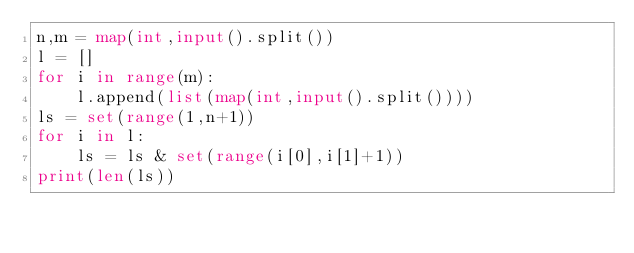Convert code to text. <code><loc_0><loc_0><loc_500><loc_500><_Python_>n,m = map(int,input().split())
l = []
for i in range(m):
    l.append(list(map(int,input().split())))
ls = set(range(1,n+1))
for i in l:
    ls = ls & set(range(i[0],i[1]+1))
print(len(ls))
</code> 